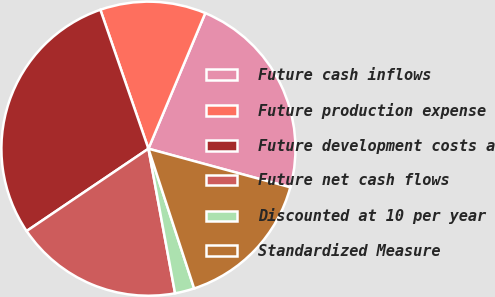Convert chart. <chart><loc_0><loc_0><loc_500><loc_500><pie_chart><fcel>Future cash inflows<fcel>Future production expense<fcel>Future development costs a<fcel>Future net cash flows<fcel>Discounted at 10 per year<fcel>Standardized Measure<nl><fcel>22.91%<fcel>11.62%<fcel>29.16%<fcel>18.44%<fcel>2.13%<fcel>15.74%<nl></chart> 